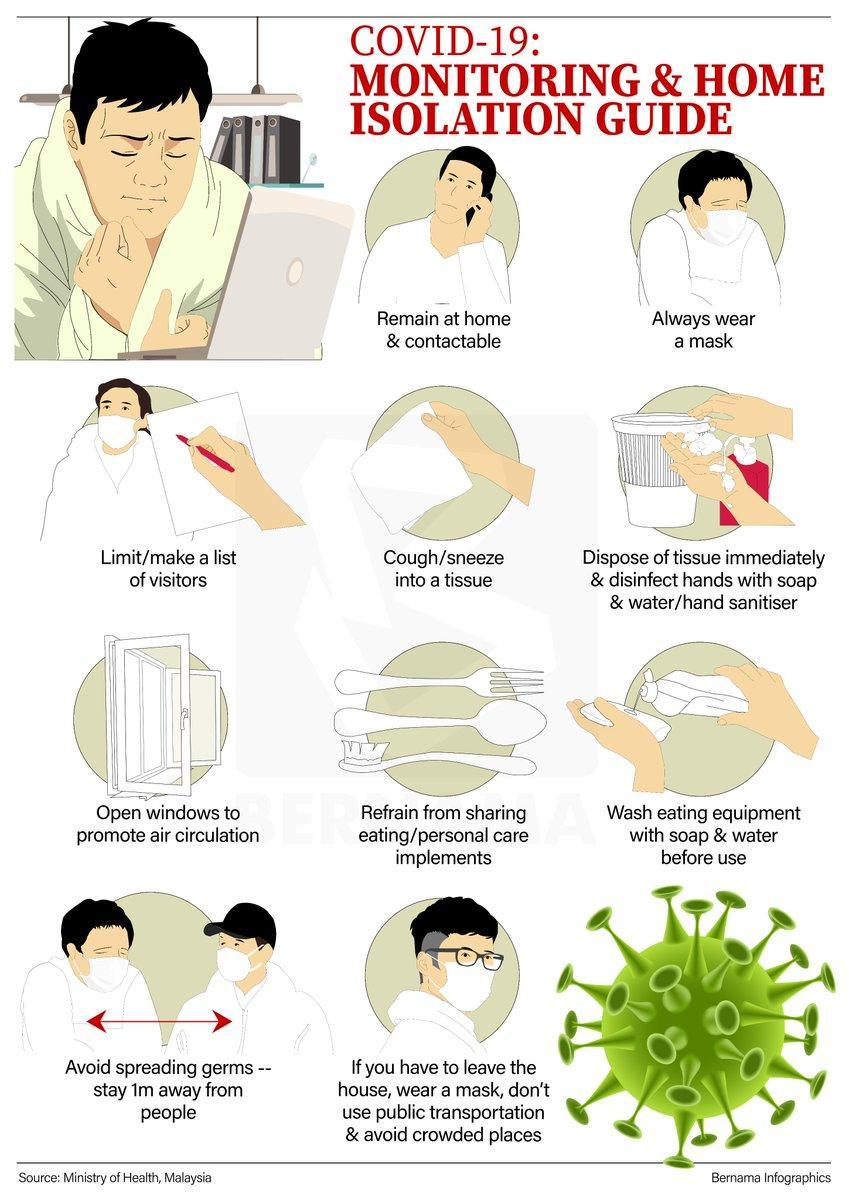What colour is the corona virus icon- green, yellow or blue?
Answer the question with a short phrase. green How many men are shown n the infographic? 7 How many people are wearing masks in the infographic? 5 